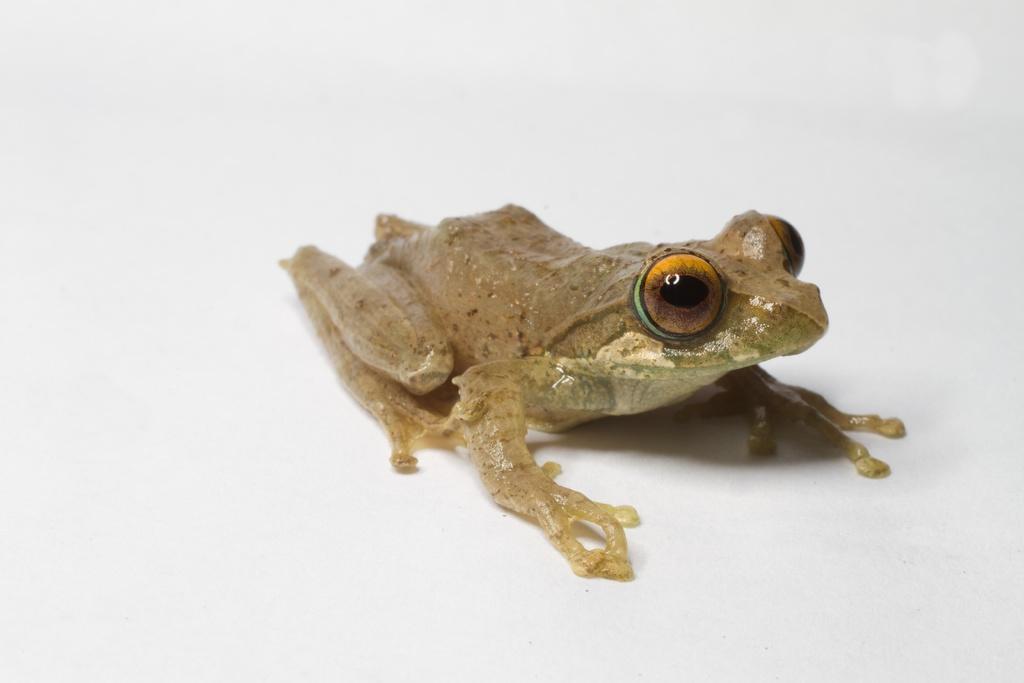Please provide a concise description of this image. In this image we can see a frog. 